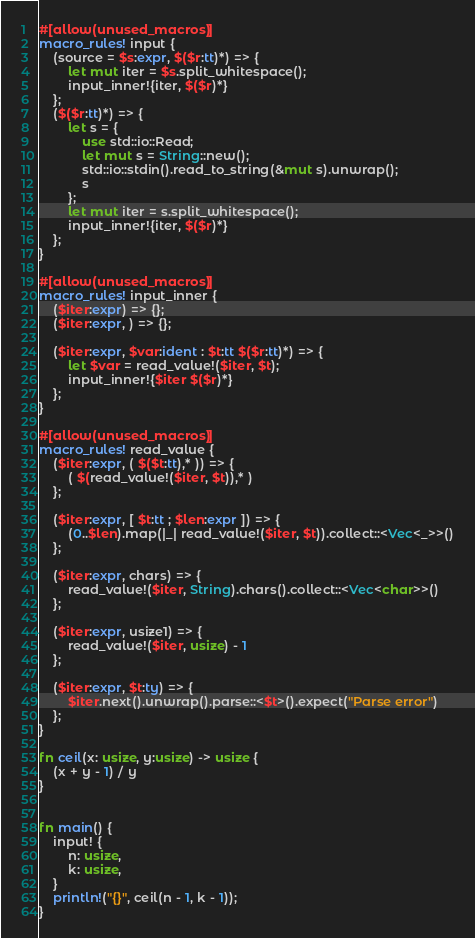<code> <loc_0><loc_0><loc_500><loc_500><_Rust_>#[allow(unused_macros)]
macro_rules! input {
    (source = $s:expr, $($r:tt)*) => {
        let mut iter = $s.split_whitespace();
        input_inner!{iter, $($r)*}
    };
    ($($r:tt)*) => {
        let s = {
            use std::io::Read;
            let mut s = String::new();
            std::io::stdin().read_to_string(&mut s).unwrap();
            s
        };
        let mut iter = s.split_whitespace();
        input_inner!{iter, $($r)*}
    };
}

#[allow(unused_macros)]
macro_rules! input_inner {
    ($iter:expr) => {};
    ($iter:expr, ) => {};

    ($iter:expr, $var:ident : $t:tt $($r:tt)*) => {
        let $var = read_value!($iter, $t);
        input_inner!{$iter $($r)*}
    };
}

#[allow(unused_macros)]
macro_rules! read_value {
    ($iter:expr, ( $($t:tt),* )) => {
        ( $(read_value!($iter, $t)),* )
    };

    ($iter:expr, [ $t:tt ; $len:expr ]) => {
        (0..$len).map(|_| read_value!($iter, $t)).collect::<Vec<_>>()
    };

    ($iter:expr, chars) => {
        read_value!($iter, String).chars().collect::<Vec<char>>()
    };

    ($iter:expr, usize1) => {
        read_value!($iter, usize) - 1
    };

    ($iter:expr, $t:ty) => {
        $iter.next().unwrap().parse::<$t>().expect("Parse error")
    };
}

fn ceil(x: usize, y:usize) -> usize {
    (x + y - 1) / y
}


fn main() {
    input! {
        n: usize,
        k: usize,
    }
    println!("{}", ceil(n - 1, k - 1));
}</code> 